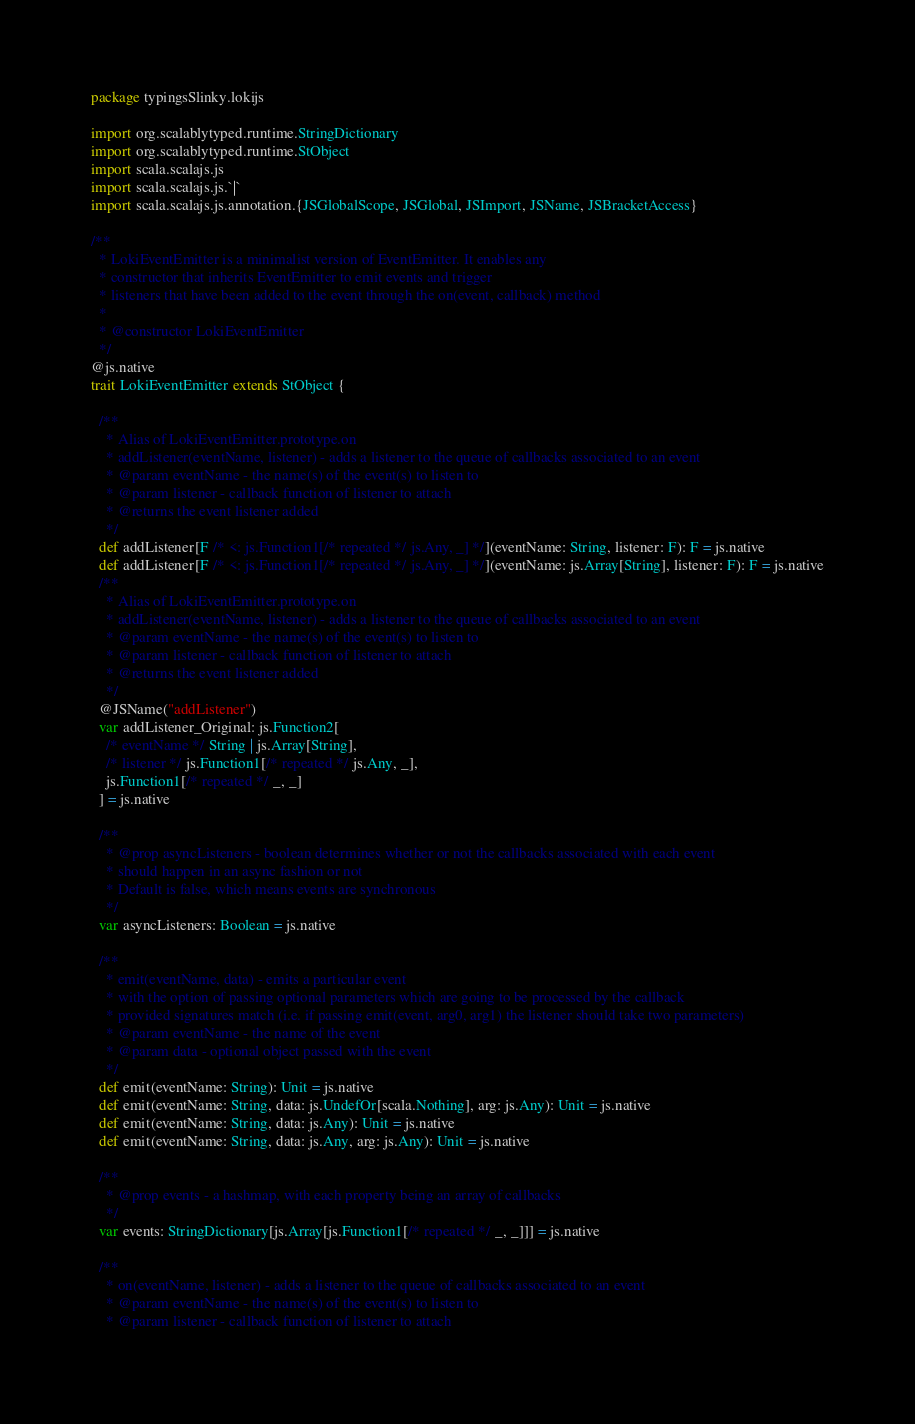Convert code to text. <code><loc_0><loc_0><loc_500><loc_500><_Scala_>package typingsSlinky.lokijs

import org.scalablytyped.runtime.StringDictionary
import org.scalablytyped.runtime.StObject
import scala.scalajs.js
import scala.scalajs.js.`|`
import scala.scalajs.js.annotation.{JSGlobalScope, JSGlobal, JSImport, JSName, JSBracketAccess}

/**
  * LokiEventEmitter is a minimalist version of EventEmitter. It enables any
  * constructor that inherits EventEmitter to emit events and trigger
  * listeners that have been added to the event through the on(event, callback) method
  *
  * @constructor LokiEventEmitter
  */
@js.native
trait LokiEventEmitter extends StObject {
  
  /**
    * Alias of LokiEventEmitter.prototype.on
    * addListener(eventName, listener) - adds a listener to the queue of callbacks associated to an event
    * @param eventName - the name(s) of the event(s) to listen to
    * @param listener - callback function of listener to attach
    * @returns the event listener added
    */
  def addListener[F /* <: js.Function1[/* repeated */ js.Any, _] */](eventName: String, listener: F): F = js.native
  def addListener[F /* <: js.Function1[/* repeated */ js.Any, _] */](eventName: js.Array[String], listener: F): F = js.native
  /**
    * Alias of LokiEventEmitter.prototype.on
    * addListener(eventName, listener) - adds a listener to the queue of callbacks associated to an event
    * @param eventName - the name(s) of the event(s) to listen to
    * @param listener - callback function of listener to attach
    * @returns the event listener added
    */
  @JSName("addListener")
  var addListener_Original: js.Function2[
    /* eventName */ String | js.Array[String], 
    /* listener */ js.Function1[/* repeated */ js.Any, _], 
    js.Function1[/* repeated */ _, _]
  ] = js.native
  
  /**
    * @prop asyncListeners - boolean determines whether or not the callbacks associated with each event
    * should happen in an async fashion or not
    * Default is false, which means events are synchronous
    */
  var asyncListeners: Boolean = js.native
  
  /**
    * emit(eventName, data) - emits a particular event
    * with the option of passing optional parameters which are going to be processed by the callback
    * provided signatures match (i.e. if passing emit(event, arg0, arg1) the listener should take two parameters)
    * @param eventName - the name of the event
    * @param data - optional object passed with the event
    */
  def emit(eventName: String): Unit = js.native
  def emit(eventName: String, data: js.UndefOr[scala.Nothing], arg: js.Any): Unit = js.native
  def emit(eventName: String, data: js.Any): Unit = js.native
  def emit(eventName: String, data: js.Any, arg: js.Any): Unit = js.native
  
  /**
    * @prop events - a hashmap, with each property being an array of callbacks
    */
  var events: StringDictionary[js.Array[js.Function1[/* repeated */ _, _]]] = js.native
  
  /**
    * on(eventName, listener) - adds a listener to the queue of callbacks associated to an event
    * @param eventName - the name(s) of the event(s) to listen to
    * @param listener - callback function of listener to attach</code> 